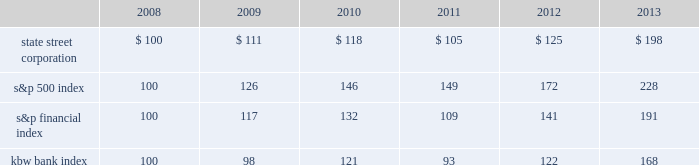Shareholder return performance presentation the graph presented below compares the cumulative total shareholder return on state street's common stock to the cumulative total return of the s&p 500 index , the s&p financial index and the kbw bank index over a five- year period .
The cumulative total shareholder return assumes the investment of $ 100 in state street common stock and in each index on december 31 , 2008 at the closing price on the last trading day of 2008 , and also assumes reinvestment of common stock dividends .
The s&p financial index is a publicly available measure of 81 of the standard & poor's 500 companies , representing 17 diversified financial services companies , 22 insurance companies , 19 real estate companies and 23 banking companies .
The kbw bank index seeks to reflect the performance of banks and thrifts that are publicly traded in the u.s. , and is composed of 24 leading national money center and regional banks and thrifts. .

What is the roi of an investment in the state street corporation from 2008 to 2011? 
Computations: ((105 - 100) / 100)
Answer: 0.05. 